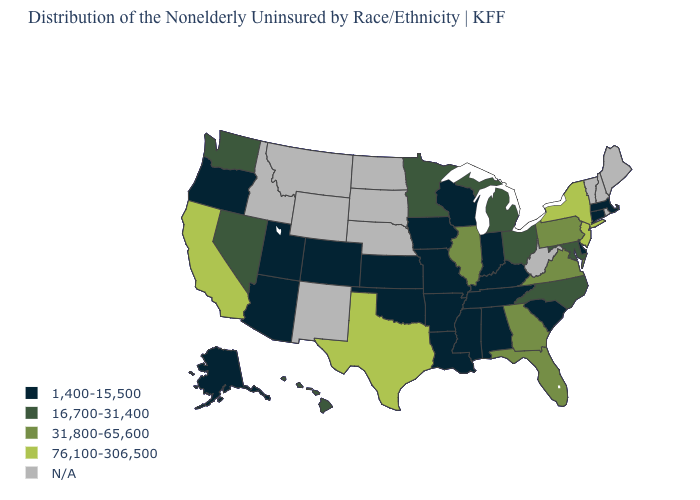What is the value of Tennessee?
Concise answer only. 1,400-15,500. Name the states that have a value in the range N/A?
Write a very short answer. Idaho, Maine, Montana, Nebraska, New Hampshire, New Mexico, North Dakota, Rhode Island, South Dakota, Vermont, West Virginia, Wyoming. Which states hav the highest value in the West?
Quick response, please. California. Name the states that have a value in the range 1,400-15,500?
Answer briefly. Alabama, Alaska, Arizona, Arkansas, Colorado, Connecticut, Delaware, Indiana, Iowa, Kansas, Kentucky, Louisiana, Massachusetts, Mississippi, Missouri, Oklahoma, Oregon, South Carolina, Tennessee, Utah, Wisconsin. What is the value of Missouri?
Keep it brief. 1,400-15,500. Among the states that border New York , does New Jersey have the highest value?
Quick response, please. Yes. What is the value of Nevada?
Give a very brief answer. 16,700-31,400. Among the states that border Virginia , does Kentucky have the highest value?
Concise answer only. No. Among the states that border Ohio , which have the highest value?
Answer briefly. Pennsylvania. Does Oklahoma have the lowest value in the South?
Keep it brief. Yes. What is the value of Alabama?
Be succinct. 1,400-15,500. Is the legend a continuous bar?
Give a very brief answer. No. Name the states that have a value in the range N/A?
Answer briefly. Idaho, Maine, Montana, Nebraska, New Hampshire, New Mexico, North Dakota, Rhode Island, South Dakota, Vermont, West Virginia, Wyoming. What is the lowest value in the USA?
Keep it brief. 1,400-15,500. What is the highest value in the MidWest ?
Write a very short answer. 31,800-65,600. 